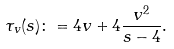<formula> <loc_0><loc_0><loc_500><loc_500>\tau _ { v } ( s ) \colon = 4 v + 4 \frac { v ^ { 2 } } { s - 4 } .</formula> 